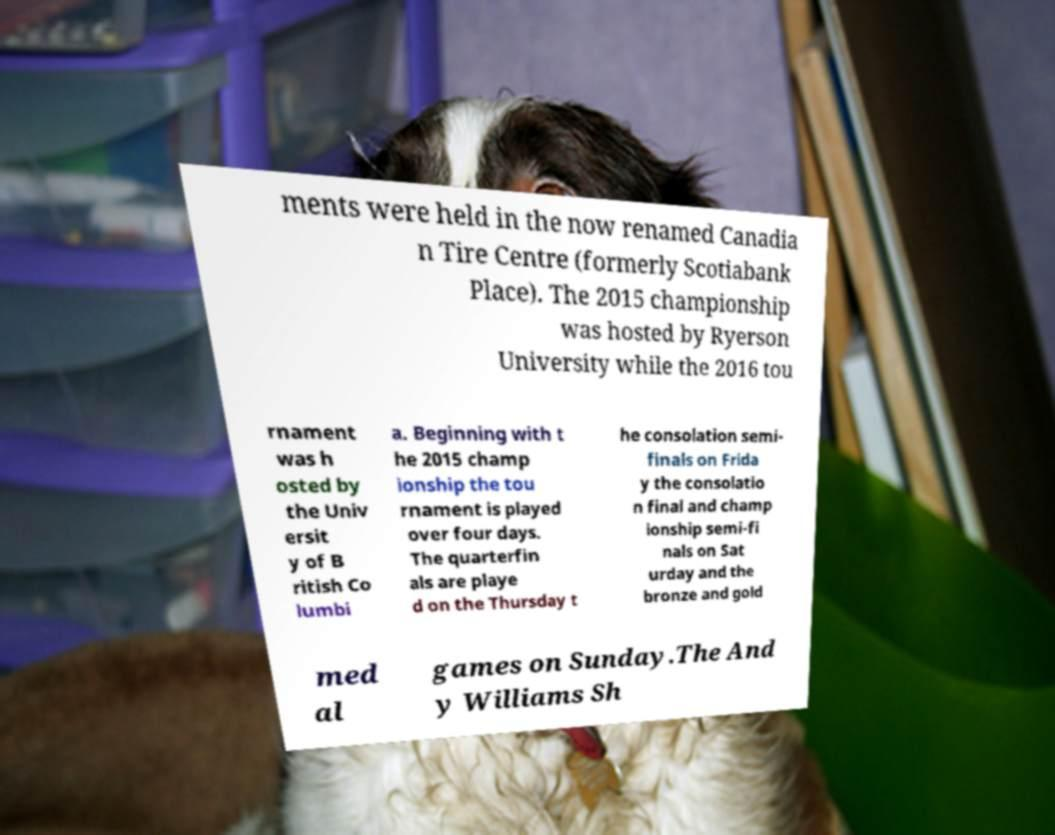Please read and relay the text visible in this image. What does it say? ments were held in the now renamed Canadia n Tire Centre (formerly Scotiabank Place). The 2015 championship was hosted by Ryerson University while the 2016 tou rnament was h osted by the Univ ersit y of B ritish Co lumbi a. Beginning with t he 2015 champ ionship the tou rnament is played over four days. The quarterfin als are playe d on the Thursday t he consolation semi- finals on Frida y the consolatio n final and champ ionship semi-fi nals on Sat urday and the bronze and gold med al games on Sunday.The And y Williams Sh 